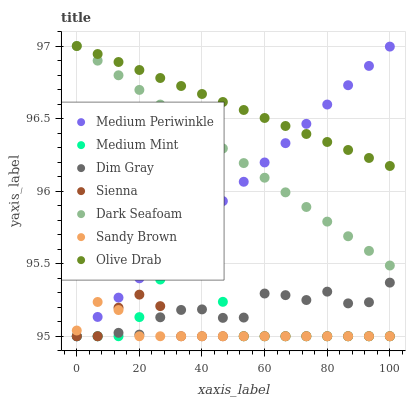Does Sandy Brown have the minimum area under the curve?
Answer yes or no. Yes. Does Olive Drab have the maximum area under the curve?
Answer yes or no. Yes. Does Dim Gray have the minimum area under the curve?
Answer yes or no. No. Does Dim Gray have the maximum area under the curve?
Answer yes or no. No. Is Dark Seafoam the smoothest?
Answer yes or no. Yes. Is Dim Gray the roughest?
Answer yes or no. Yes. Is Medium Periwinkle the smoothest?
Answer yes or no. No. Is Medium Periwinkle the roughest?
Answer yes or no. No. Does Medium Mint have the lowest value?
Answer yes or no. Yes. Does Dark Seafoam have the lowest value?
Answer yes or no. No. Does Olive Drab have the highest value?
Answer yes or no. Yes. Does Dim Gray have the highest value?
Answer yes or no. No. Is Dim Gray less than Olive Drab?
Answer yes or no. Yes. Is Olive Drab greater than Medium Mint?
Answer yes or no. Yes. Does Medium Periwinkle intersect Sienna?
Answer yes or no. Yes. Is Medium Periwinkle less than Sienna?
Answer yes or no. No. Is Medium Periwinkle greater than Sienna?
Answer yes or no. No. Does Dim Gray intersect Olive Drab?
Answer yes or no. No. 